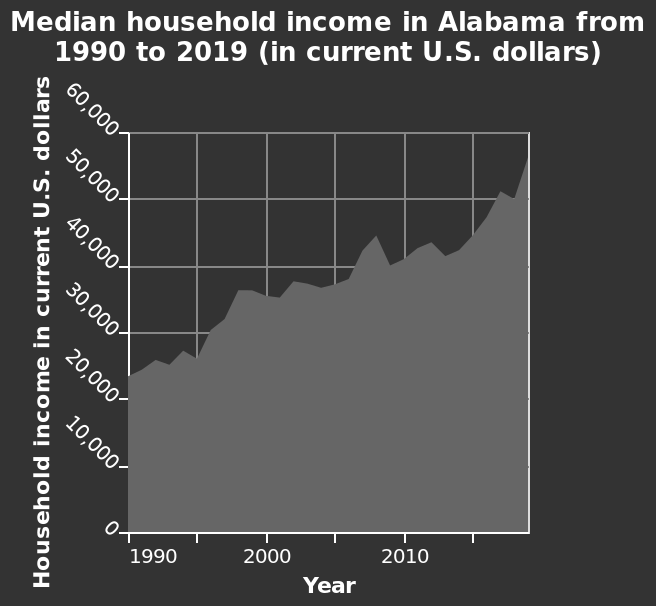<image>
please summary the statistics and relations of the chart There is a progressive increase in the average income of households in Alabama from approximately 23000 dollars in 1990 to 55000 dollars in 2020. What is plotted on the x-axis?  The x-axis plots the year from 1990 to 2015 as a linear scale. please describe the details of the chart This area graph is labeled Median household income in Alabama from 1990 to 2019 (in current U.S. dollars). The x-axis plots Year as linear scale of range 1990 to 2015 while the y-axis measures Household income in current U.S. dollars using linear scale of range 0 to 60,000. What was the average income of households in Alabama in 1990?  The average income of households in Alabama in 1990 was approximately 23000 dollars. 